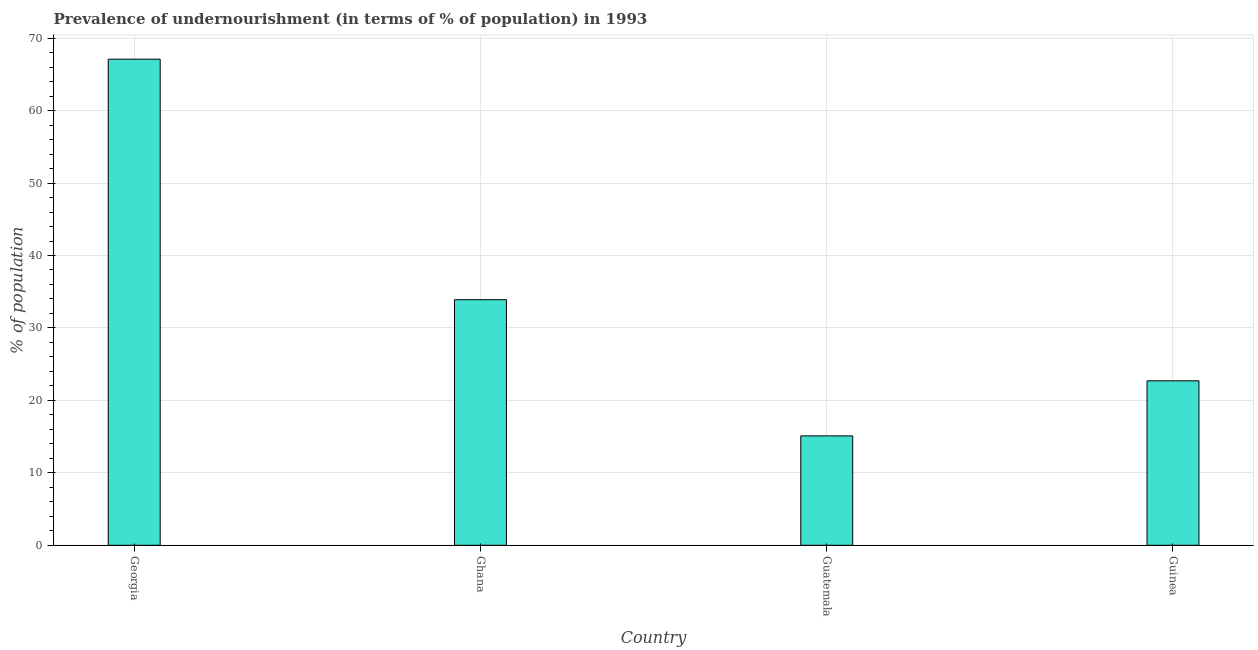Does the graph contain any zero values?
Give a very brief answer. No. Does the graph contain grids?
Your response must be concise. Yes. What is the title of the graph?
Provide a short and direct response. Prevalence of undernourishment (in terms of % of population) in 1993. What is the label or title of the Y-axis?
Make the answer very short. % of population. What is the percentage of undernourished population in Georgia?
Ensure brevity in your answer.  67.1. Across all countries, what is the maximum percentage of undernourished population?
Your answer should be compact. 67.1. Across all countries, what is the minimum percentage of undernourished population?
Make the answer very short. 15.1. In which country was the percentage of undernourished population maximum?
Give a very brief answer. Georgia. In which country was the percentage of undernourished population minimum?
Give a very brief answer. Guatemala. What is the sum of the percentage of undernourished population?
Offer a terse response. 138.8. What is the average percentage of undernourished population per country?
Give a very brief answer. 34.7. What is the median percentage of undernourished population?
Offer a very short reply. 28.3. In how many countries, is the percentage of undernourished population greater than 48 %?
Make the answer very short. 1. What is the ratio of the percentage of undernourished population in Ghana to that in Guatemala?
Offer a very short reply. 2.25. Is the percentage of undernourished population in Georgia less than that in Guinea?
Ensure brevity in your answer.  No. Is the difference between the percentage of undernourished population in Georgia and Guinea greater than the difference between any two countries?
Provide a succinct answer. No. What is the difference between the highest and the second highest percentage of undernourished population?
Your answer should be very brief. 33.2. Is the sum of the percentage of undernourished population in Ghana and Guinea greater than the maximum percentage of undernourished population across all countries?
Offer a terse response. No. What is the difference between the highest and the lowest percentage of undernourished population?
Your answer should be very brief. 52. In how many countries, is the percentage of undernourished population greater than the average percentage of undernourished population taken over all countries?
Offer a very short reply. 1. How many bars are there?
Your response must be concise. 4. Are all the bars in the graph horizontal?
Keep it short and to the point. No. What is the difference between two consecutive major ticks on the Y-axis?
Your answer should be compact. 10. What is the % of population in Georgia?
Your answer should be compact. 67.1. What is the % of population in Ghana?
Ensure brevity in your answer.  33.9. What is the % of population in Guatemala?
Ensure brevity in your answer.  15.1. What is the % of population of Guinea?
Ensure brevity in your answer.  22.7. What is the difference between the % of population in Georgia and Ghana?
Provide a succinct answer. 33.2. What is the difference between the % of population in Georgia and Guatemala?
Provide a succinct answer. 52. What is the difference between the % of population in Georgia and Guinea?
Give a very brief answer. 44.4. What is the ratio of the % of population in Georgia to that in Ghana?
Keep it short and to the point. 1.98. What is the ratio of the % of population in Georgia to that in Guatemala?
Ensure brevity in your answer.  4.44. What is the ratio of the % of population in Georgia to that in Guinea?
Offer a very short reply. 2.96. What is the ratio of the % of population in Ghana to that in Guatemala?
Your answer should be very brief. 2.25. What is the ratio of the % of population in Ghana to that in Guinea?
Provide a short and direct response. 1.49. What is the ratio of the % of population in Guatemala to that in Guinea?
Provide a succinct answer. 0.67. 